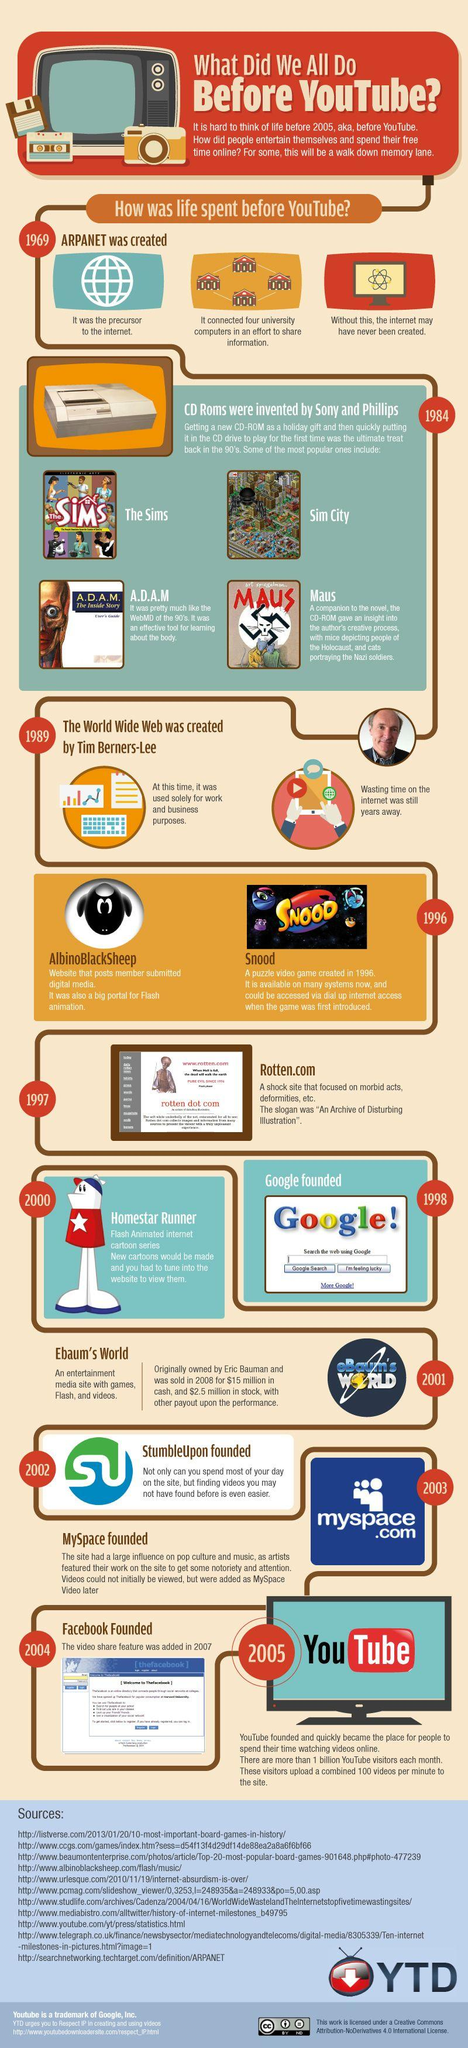Indicate a few pertinent items in this graphic. Google was founded in 1998. Sir Tim Berners-Lee, the inventor of the World Wide Web, introduced the concept in 1989. Facebook was founded in 2004. 